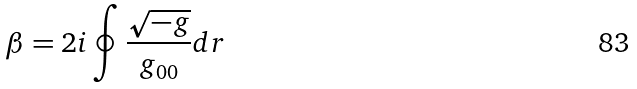<formula> <loc_0><loc_0><loc_500><loc_500>\beta = 2 i \oint \frac { \sqrt { - g } } { g _ { 0 0 } } d r</formula> 